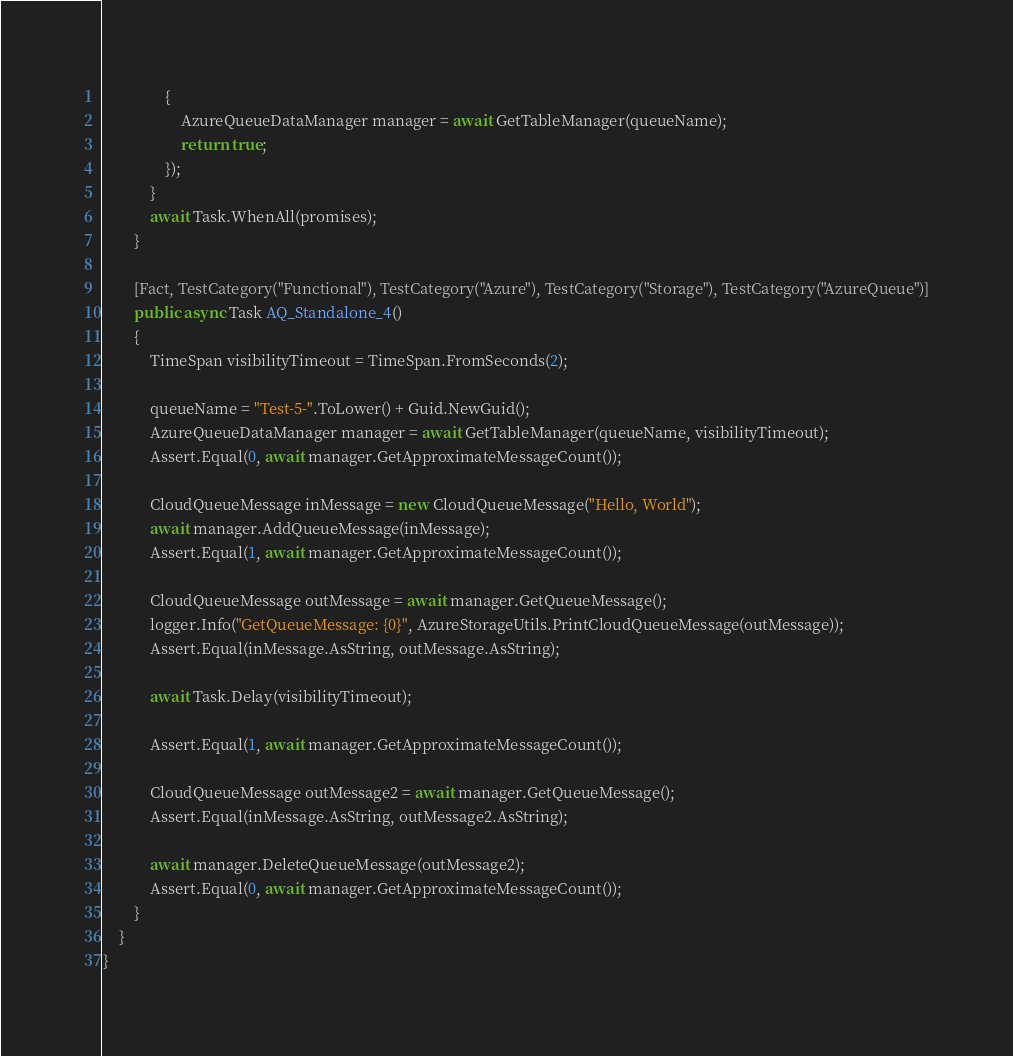<code> <loc_0><loc_0><loc_500><loc_500><_C#_>                {
                    AzureQueueDataManager manager = await GetTableManager(queueName);
                    return true;
                });
            }
            await Task.WhenAll(promises);
        }

        [Fact, TestCategory("Functional"), TestCategory("Azure"), TestCategory("Storage"), TestCategory("AzureQueue")]
        public async Task AQ_Standalone_4()
        {
            TimeSpan visibilityTimeout = TimeSpan.FromSeconds(2);

            queueName = "Test-5-".ToLower() + Guid.NewGuid();
            AzureQueueDataManager manager = await GetTableManager(queueName, visibilityTimeout);
            Assert.Equal(0, await manager.GetApproximateMessageCount());

            CloudQueueMessage inMessage = new CloudQueueMessage("Hello, World");
            await manager.AddQueueMessage(inMessage);
            Assert.Equal(1, await manager.GetApproximateMessageCount());
            
            CloudQueueMessage outMessage = await manager.GetQueueMessage();
            logger.Info("GetQueueMessage: {0}", AzureStorageUtils.PrintCloudQueueMessage(outMessage));
            Assert.Equal(inMessage.AsString, outMessage.AsString);

            await Task.Delay(visibilityTimeout);

            Assert.Equal(1, await manager.GetApproximateMessageCount());

            CloudQueueMessage outMessage2 = await manager.GetQueueMessage();
            Assert.Equal(inMessage.AsString, outMessage2.AsString);

            await manager.DeleteQueueMessage(outMessage2);
            Assert.Equal(0, await manager.GetApproximateMessageCount());
        }
    }
}
</code> 